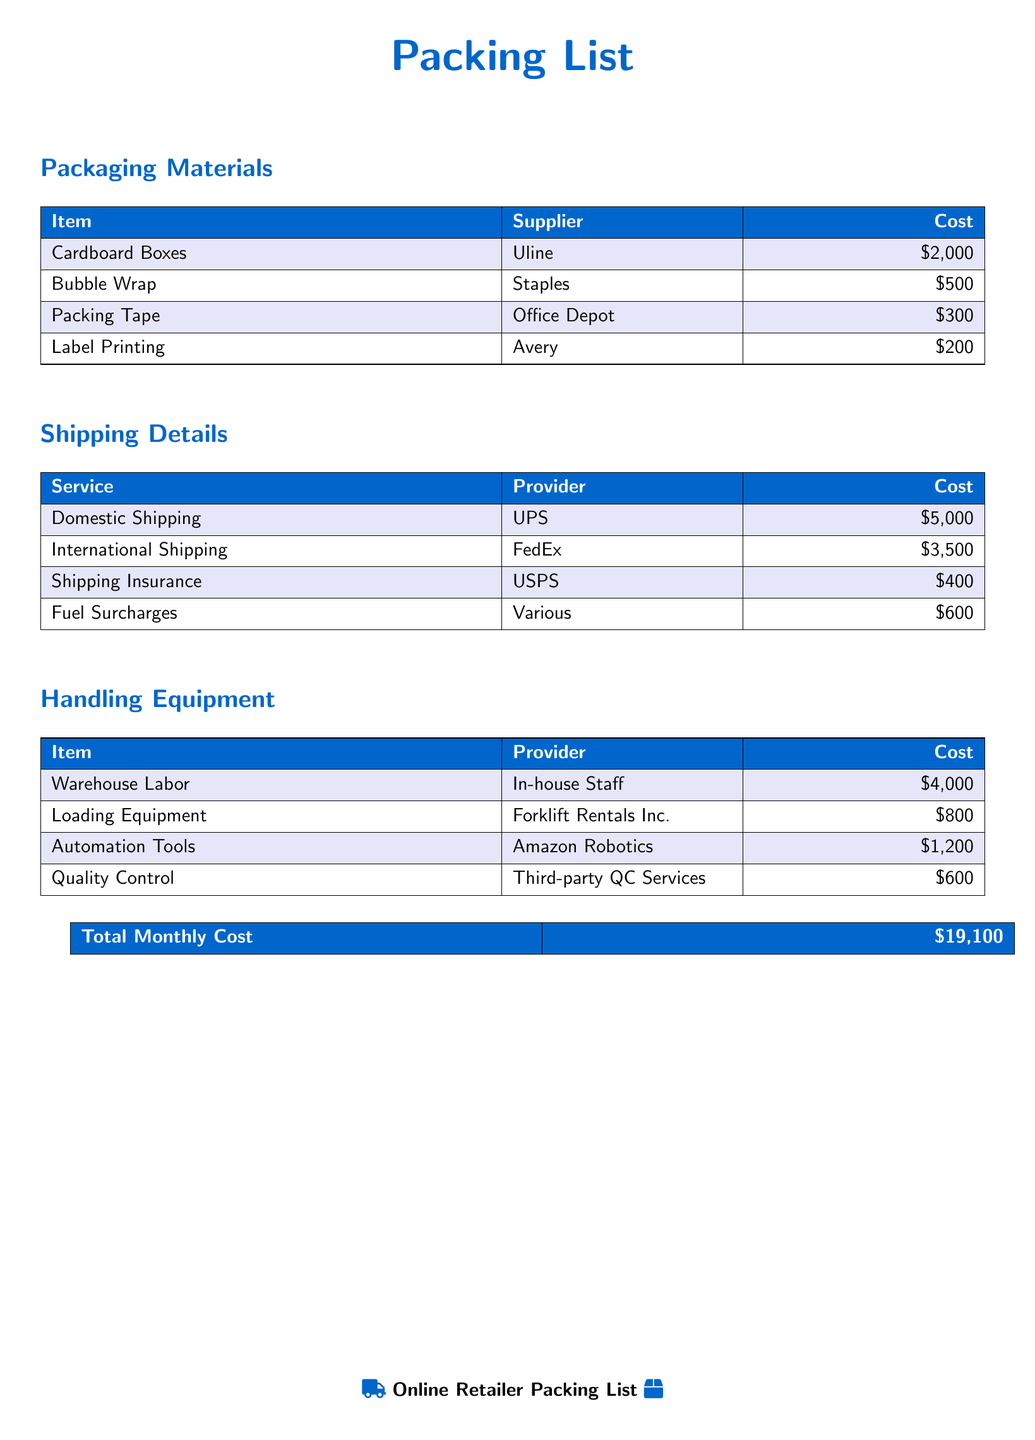What is the total monthly cost? The total monthly cost is provided at the end of the document, summing up all costs listed.
Answer: $19,100 Who is the supplier for cardboard boxes? The document specifies the supplier details for packaging materials, showing "Uline" for cardboard boxes.
Answer: Uline How much does bubble wrap cost? The cost of bubble wrap is mentioned in the packaging materials section of the document.
Answer: $500 Which service provides international shipping? The document indicates "FedEx" as the provider for international shipping.
Answer: FedEx What is the cost of warehouse labor? The document lists warehouse labor cost under handling equipment, which indicates the expense.
Answer: $4,000 What item has the highest shipping cost? The shipping details section specifies that domestic shipping has the highest cost compared to other shipping services.
Answer: $5,000 What is the cost of the loading equipment? The cost for loading equipment is provided in the handling equipment section of the document.
Answer: $800 How much is spent on shipping insurance? Shipping insurance cost is explicitly mentioned in the shipping details section.
Answer: $400 Which company provides automation tools? The provider for automation tools is stated in the handling equipment section of the document.
Answer: Amazon Robotics 